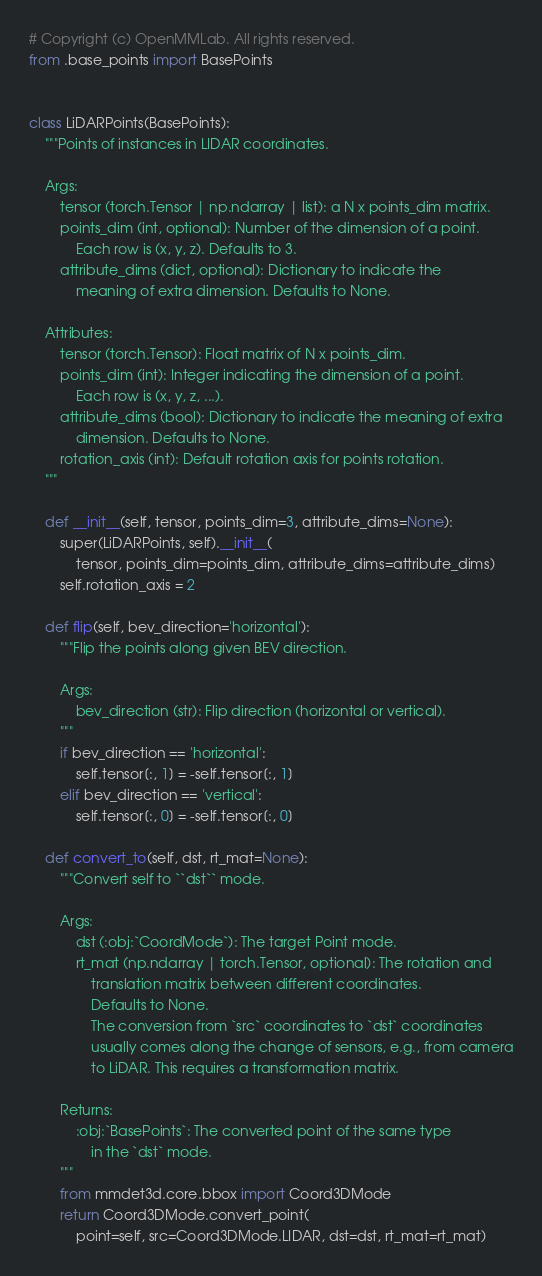Convert code to text. <code><loc_0><loc_0><loc_500><loc_500><_Python_># Copyright (c) OpenMMLab. All rights reserved.
from .base_points import BasePoints


class LiDARPoints(BasePoints):
    """Points of instances in LIDAR coordinates.

    Args:
        tensor (torch.Tensor | np.ndarray | list): a N x points_dim matrix.
        points_dim (int, optional): Number of the dimension of a point.
            Each row is (x, y, z). Defaults to 3.
        attribute_dims (dict, optional): Dictionary to indicate the
            meaning of extra dimension. Defaults to None.

    Attributes:
        tensor (torch.Tensor): Float matrix of N x points_dim.
        points_dim (int): Integer indicating the dimension of a point.
            Each row is (x, y, z, ...).
        attribute_dims (bool): Dictionary to indicate the meaning of extra
            dimension. Defaults to None.
        rotation_axis (int): Default rotation axis for points rotation.
    """

    def __init__(self, tensor, points_dim=3, attribute_dims=None):
        super(LiDARPoints, self).__init__(
            tensor, points_dim=points_dim, attribute_dims=attribute_dims)
        self.rotation_axis = 2

    def flip(self, bev_direction='horizontal'):
        """Flip the points along given BEV direction.

        Args:
            bev_direction (str): Flip direction (horizontal or vertical).
        """
        if bev_direction == 'horizontal':
            self.tensor[:, 1] = -self.tensor[:, 1]
        elif bev_direction == 'vertical':
            self.tensor[:, 0] = -self.tensor[:, 0]

    def convert_to(self, dst, rt_mat=None):
        """Convert self to ``dst`` mode.

        Args:
            dst (:obj:`CoordMode`): The target Point mode.
            rt_mat (np.ndarray | torch.Tensor, optional): The rotation and
                translation matrix between different coordinates.
                Defaults to None.
                The conversion from `src` coordinates to `dst` coordinates
                usually comes along the change of sensors, e.g., from camera
                to LiDAR. This requires a transformation matrix.

        Returns:
            :obj:`BasePoints`: The converted point of the same type
                in the `dst` mode.
        """
        from mmdet3d.core.bbox import Coord3DMode
        return Coord3DMode.convert_point(
            point=self, src=Coord3DMode.LIDAR, dst=dst, rt_mat=rt_mat)
</code> 